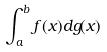<formula> <loc_0><loc_0><loc_500><loc_500>\int _ { a } ^ { b } f ( x ) d g ( x )</formula> 